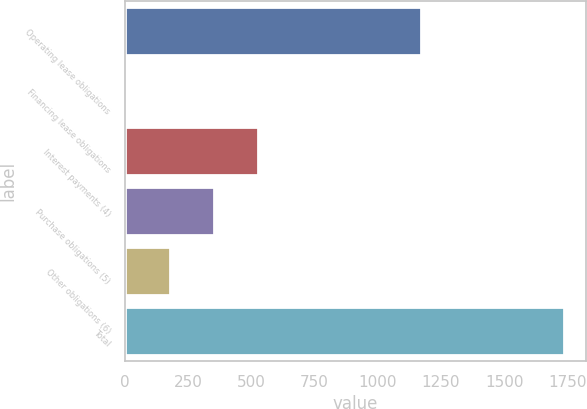Convert chart. <chart><loc_0><loc_0><loc_500><loc_500><bar_chart><fcel>Operating lease obligations<fcel>Financing lease obligations<fcel>Interest payments (4)<fcel>Purchase obligations (5)<fcel>Other obligations (6)<fcel>Total<nl><fcel>1172.9<fcel>6.4<fcel>525.49<fcel>352.46<fcel>179.43<fcel>1736.7<nl></chart> 